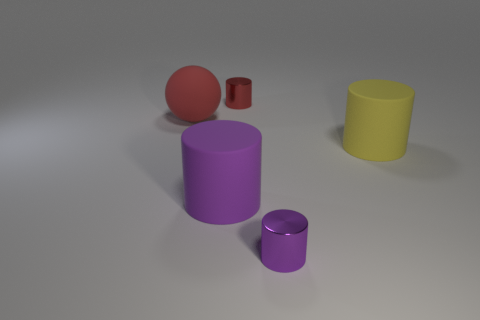Add 2 red metal cubes. How many objects exist? 7 Subtract all cylinders. How many objects are left? 1 Subtract all big rubber cylinders. Subtract all tiny metal cylinders. How many objects are left? 1 Add 4 small metal objects. How many small metal objects are left? 6 Add 1 metallic things. How many metallic things exist? 3 Subtract 0 blue cubes. How many objects are left? 5 